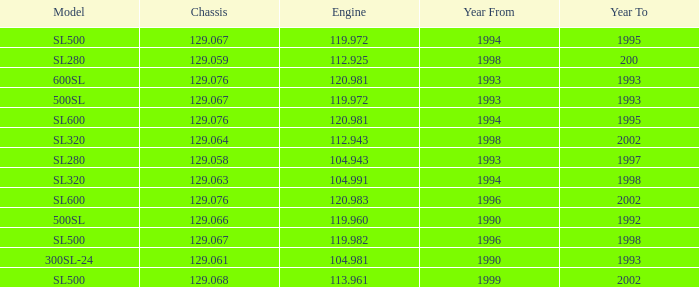Which Engine has a Model of sl500, and a Chassis smaller than 129.067? None. 